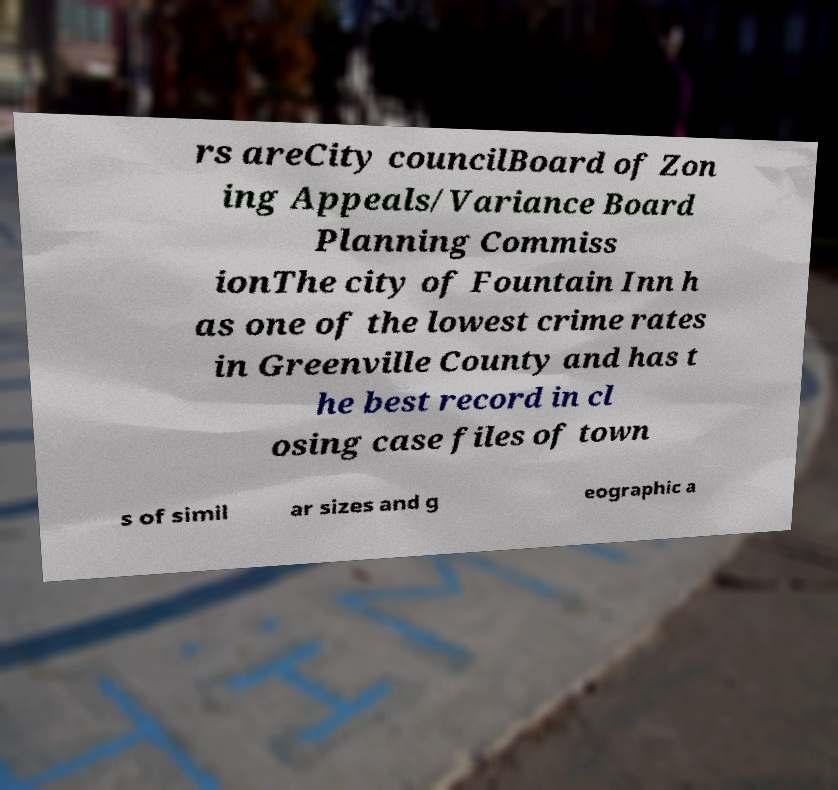Can you accurately transcribe the text from the provided image for me? rs areCity councilBoard of Zon ing Appeals/Variance Board Planning Commiss ionThe city of Fountain Inn h as one of the lowest crime rates in Greenville County and has t he best record in cl osing case files of town s of simil ar sizes and g eographic a 